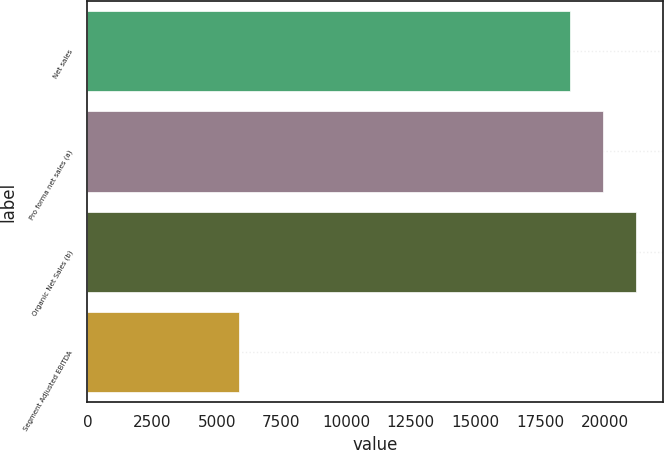Convert chart. <chart><loc_0><loc_0><loc_500><loc_500><bar_chart><fcel>Net sales<fcel>Pro forma net sales (a)<fcel>Organic Net Sales (b)<fcel>Segment Adjusted EBITDA<nl><fcel>18641<fcel>19918.9<fcel>21196.8<fcel>5862<nl></chart> 